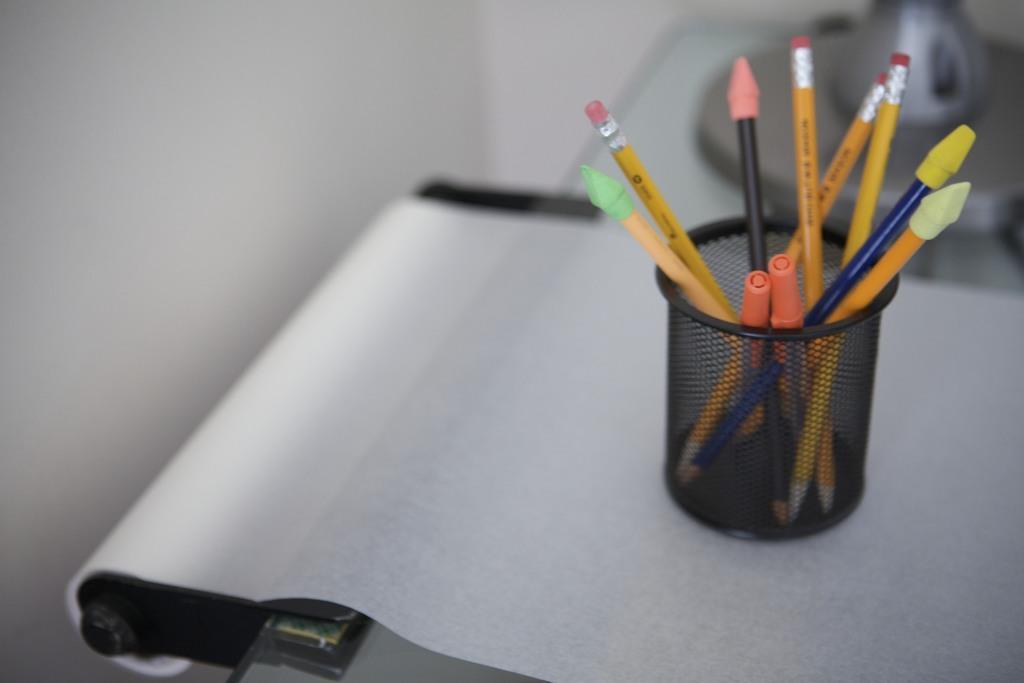Could you give a brief overview of what you see in this image? In this image we can see a sheet of paper, pen holder and some stationary in it. 